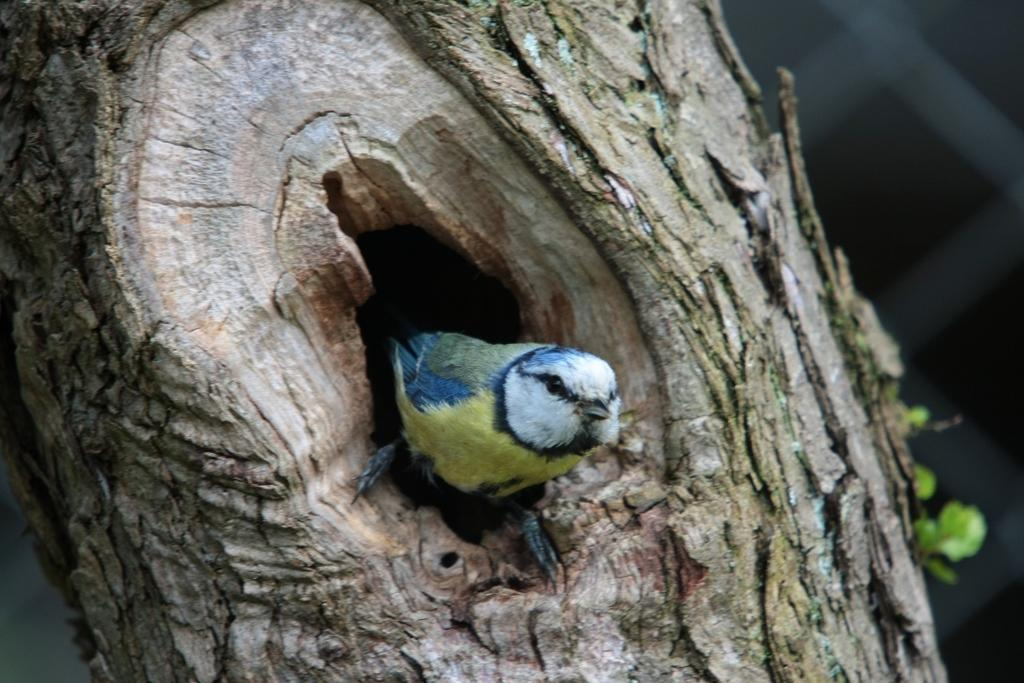What type of animal can be seen in the image? There is a bird in the image. Where is the bird located? The bird is on a tree. What can be seen on the tree besides the bird? Leaves are visible in the image. What type of skin condition does the bird have in the image? There is no indication of any skin condition on the bird in the image. 